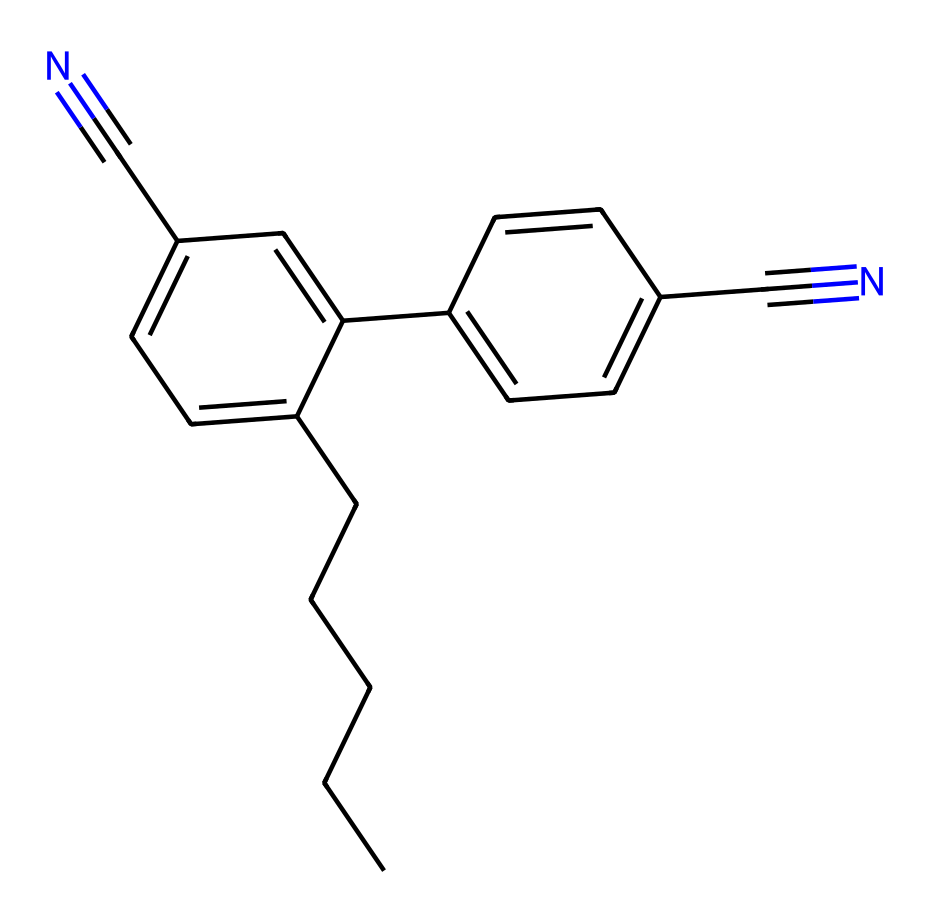What is the total number of carbon atoms in the structure? By analyzing the SMILES representation, we can identify the number of carbon atoms by counting each "C" in the string. The structure explicitly shows 12 carbon atoms.
Answer: 12 How many triple bonds are present in this chemical? In the provided SMILES representation, the triple bond is indicated by "C#N." Observing the structure, we see that there are 2 instances of "C#N," indicating 2 triple bonds in total.
Answer: 2 What functional groups can be identified in this liquid crystal structure? The structure contains cyanide groups, as indicated by "C#N," and also contains arene rings typical for liquid crystals, which have alternating double bonds (indicated by the "C=CC"). The presence of these groups indicates functionalities typical of liquid crystals.
Answer: cyanide and arene What are the total numbers of double bonds present in this structure? By reviewing the SMILES, we note that double bonds are represented by "=". Counting these throughout the molecule, there are a total of 4 double bonds present in the entire structure.
Answer: 4 Is this chemical likely to be polar or nonpolar? The presence of polar functional groups, such as the cyanide (C#N), suggests that it will have regions of polarity. However, the overall long carbon chain may impart some nonpolar characteristics. Collectively, this chemical is likely to have both polar and nonpolar characteristics, depending on its orientation.
Answer: polar What is the key role of this type of compound in liquid crystal displays? This compound's structure allows for the alignment of liquid molecules, crucial for modulating light in LCDs. The anisotropic properties arising from the rigid structure help control the orientation of liquid crystal molecules under electric fields, effectively impacting display performance.
Answer: modulation 